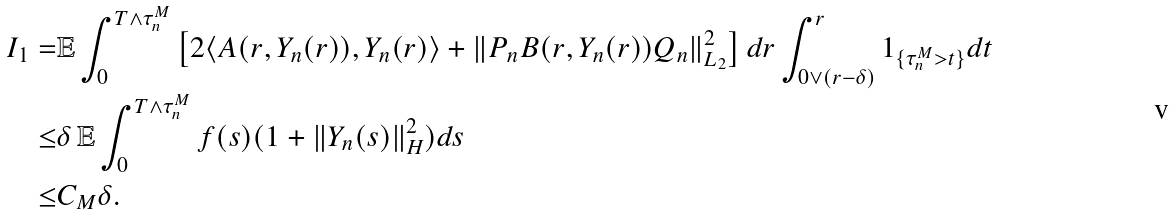Convert formula to latex. <formula><loc_0><loc_0><loc_500><loc_500>I _ { 1 } = & \mathbb { E } \int _ { 0 } ^ { T \wedge \tau _ { n } ^ { M } } \left [ 2 \langle A ( r , Y _ { n } ( r ) ) , Y _ { n } ( r ) \rangle + \| P _ { n } B ( r , Y _ { n } ( r ) ) Q _ { n } \| _ { L _ { 2 } } ^ { 2 } \right ] d r \int _ { 0 \vee ( r - \delta ) } ^ { r } 1 _ { \{ \tau _ { n } ^ { M } > t \} } d t \\ \leq & \delta \, \mathbb { E } \int _ { 0 } ^ { T \wedge \tau _ { n } ^ { M } } f ( s ) ( 1 + \| Y _ { n } ( s ) \| _ { H } ^ { 2 } ) d s \\ \leq & C _ { M } \delta .</formula> 